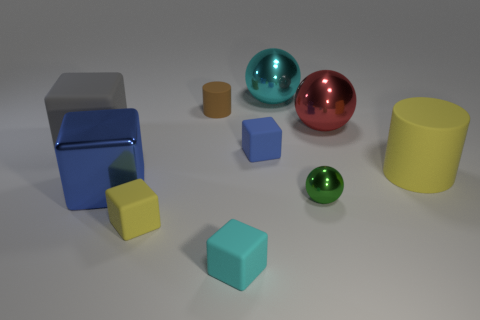Subtract all green cubes. Subtract all brown balls. How many cubes are left? 5 Subtract all cylinders. How many objects are left? 8 Subtract 1 gray cubes. How many objects are left? 9 Subtract all tiny yellow metal balls. Subtract all gray matte objects. How many objects are left? 9 Add 3 big blue cubes. How many big blue cubes are left? 4 Add 4 small purple rubber cubes. How many small purple rubber cubes exist? 4 